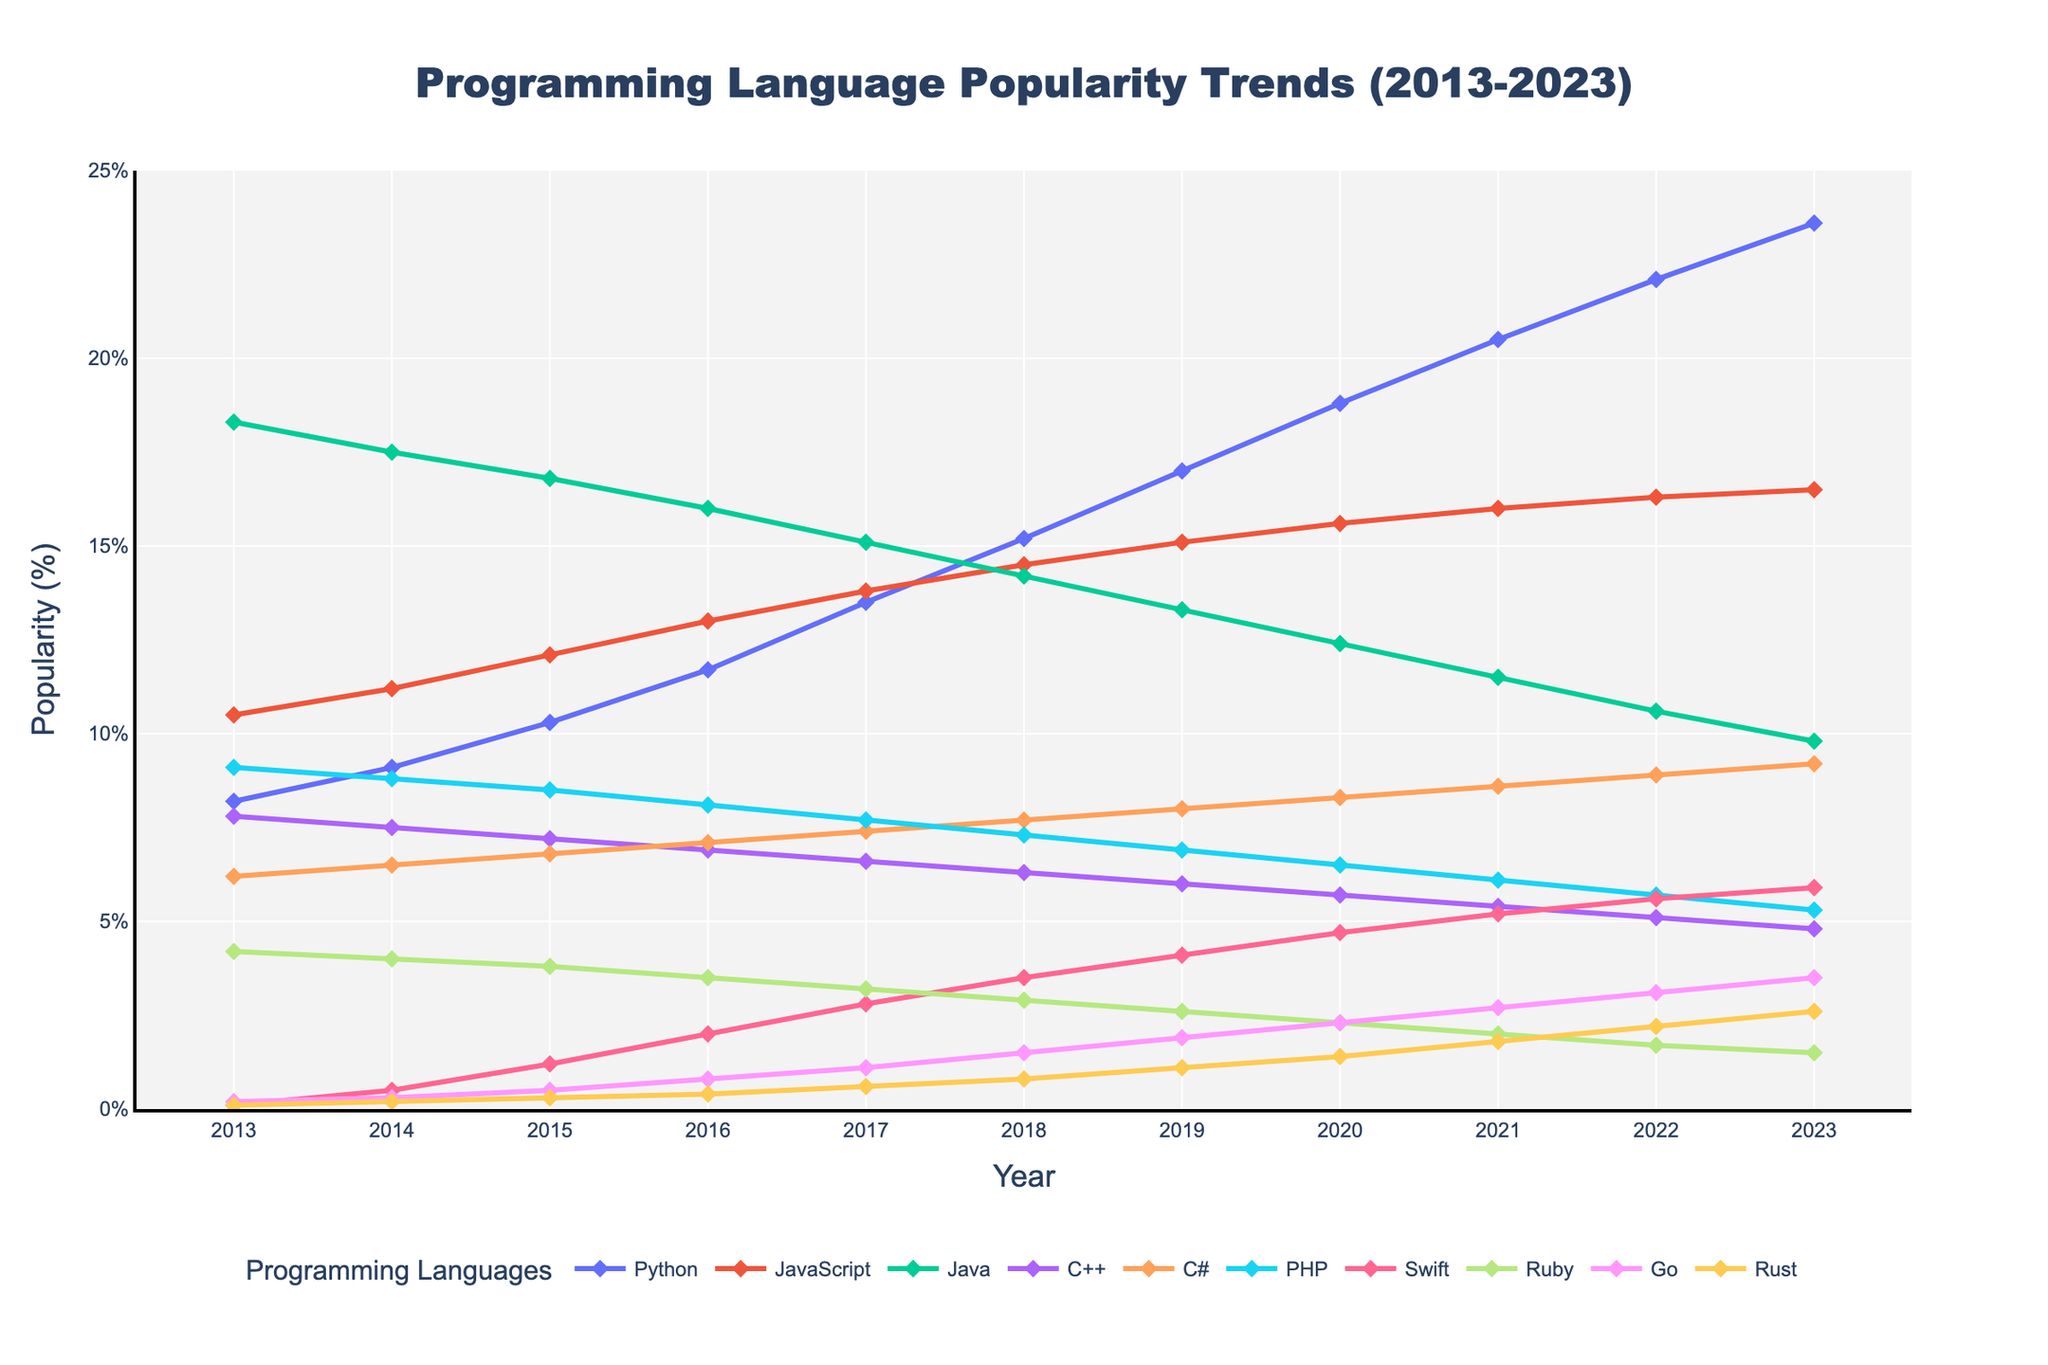what is the overall trend of Python's popularity from 2013 to 2023? The line representing Python shows a consistent upward trend from 8.2% in 2013 to 23.6% in 2023, indicating a steady increase in its popularity over the years.
Answer: Increasing Between Java and JavaScript, which language experienced a more significant decline in popularity from 2013 to 2023? Calculate the difference for each language: Java (18.3% in 2013 to 9.8% in 2023) results in a decline of 8.5%, JavaScript (10.5% in 2013 to 16.5% in 2023) experienced no decline but an increase instead.
Answer: Java Which year did Swift overtake PHP in popularity? By observing the intersection of the lines representing Swift and PHP, Swift overtook PHP in 2017 when Swift's popularity reached 2.8%, surpassing PHP's 2.7%.
Answer: 2017 In what year did Rust become more popular than Ruby? Trace the point where Rust's popularity line crosses above Ruby's. Rust surpasses Ruby in 2021 with Rust at 1.8% and Ruby declining to 1.7%.
Answer: 2021 From 2013 to 2023, which language showed the most volatile trend in popularity? Among the languages, Python consistently increases, indicating stability, whereas C# shows some fluctuations. However, no language other than PHP went from 9.1% in 2013 to 5.3% in 2023 with minor ups and downs, indicating volatility.
Answer: PHP What was the average popularity of Go from 2013 to 2023? Sum the popularity percentages of Go for each year and divide by the number of years (11): (0.2 + 0.3 + 0.5 + 0.8 + 1.1 + 1.5 + 1.9 + 2.3 + 2.7 + 3.1 + 3.5) / 11 = 20 / 11 ≈ 1.82%
Answer: 1.82% Comparing Python and Java, how many years did Python take to become more popular than Java? Python starts at 8.2% and Java at 18.3% in 2013. Python surpasses Java in 2017 when Python reaches 13.5% while Java is at 15.1%.
Answer: 4 years What is the total difference in popularity between Rust and Go in 2023? Rust's popularity in 2023 is 2.6% and Go's is 3.5%. Subtract Rust's value from Go's: 3.5% - 2.6% = 0.9%.
Answer: 0.9% In which years did PHP experience a decline in popularity? Identify the years where PHP’s percentage decreased compared to the previous year by observing the downward slopes: 2013-2014, 2014-2015, 2015-2016, 2016-2017, 2017-2018, 2018-2019, 2019-2020, 2020-2021, 2021-2022, 2022-2023.
Answer: 2013-2015, 2016-2023 Which language had the highest increase in popularity from 2013 to 2023? Calculating the increase by subtracting the 2013 value from the 2023 value for each language: Python (23.6 - 8.2 = 15.4), JavaScript (16.5 - 10.5 = 6), Java (9.8 - 18.3 = -8.5), C++ (4.8 - 7.8 = -3), C# (9.2 - 6.2 = 3), PHP (5.3 - 9.1 = -3.8), Swift (5.9 - 0.1 = 5.8), Ruby (1.5 - 4.2 = -2.7), Go (3.5 - 0.2 = 3.3), Rust (2.6 - 0.1 = 2.5).
Answer: Python 